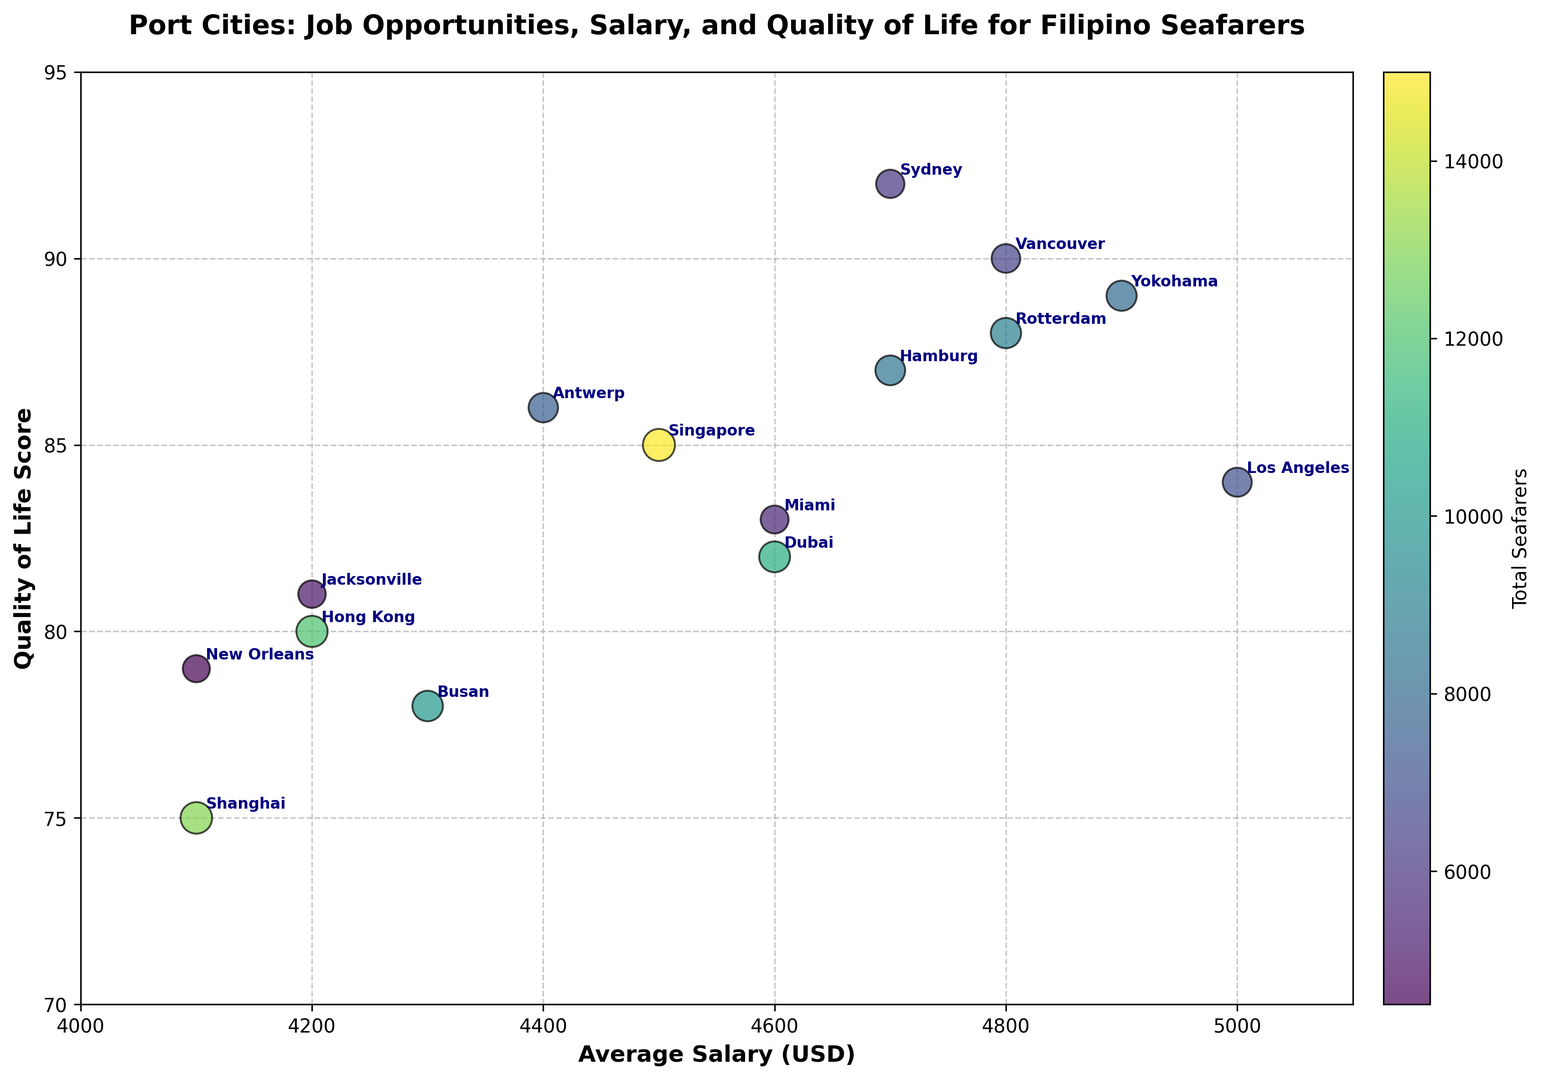What city has the highest Quality of Life score? The Quality of Life scores are represented on the vertical axis of the bubble chart. By observing the chart, Sydney has a Quality of Life score of 92, which is the highest.
Answer: Sydney Which city offers the highest average salary for Filipino seafarers? The average salaries are represented on the horizontal axis of the bubble chart. By checking the chart, Los Angeles offers the highest average salary of 5000 USD.
Answer: Los Angeles Which city has the largest bubble size, indicating the most job opportunities? The size of the bubbles represents the job opportunities. The bubble for Singapore is the largest, indicating it has the highest job opportunities score of 95.
Answer: Singapore Are there any cities with a Quality of Life score of 90 or higher? To determine this, we observe the vertical axis and check for any bubbles positioned 90 or higher. Vancouver (90) and Sydney (92) both meet this criterion.
Answer: Vancouver, Sydney Which city has a higher average salary: Hong Kong or Dubai? To compare the average salaries, we check the horizontal positions of Hong Kong and Dubai's bubbles. Hong Kong has an average salary of 4200 USD, while Dubai has 4600 USD. Therefore, Dubai offers a higher average salary.
Answer: Dubai Which city with an average salary less than 4800 USD has the highest Quality of Life score? First, we identify cities with average salaries less than 4800 USD. Then, among them, we look for the one with the highest vertical position. The city is Antwerp, which has a Quality of Life score of 86.
Answer: Antwerp What is the difference in the Quality of Life scores between Rotterdam and Yokohama? Rotterdam has a Quality of Life score of 88, and Yokohama has a score of 89. The difference is 89 - 88 = 1.
Answer: 1 Which port city has the fewest total seafarers? The color of the bubbles represents the total seafarers, with lighter colors indicating fewer seafarers. The lightest color corresponds to New Orleans, with 4500 total seafarers.
Answer: New Orleans Does Shanghai have more job opportunities than Busan and less than Singapore? We compare the job opportunities of the three cities. Shanghai has a score of 92, Busan 86, and Singapore 95. Thus, Shanghai has more job opportunities than Busan but fewer than Singapore.
Answer: Yes Which cities offer an average salary of 4700 USD? We look for bubbles positioned at 4700 on the horizontal axis. Hamburg, Sydney, and Jacksonville all offer an average salary of 4700 USD.
Answer: Hamburg, Sydney, Jacksonville 